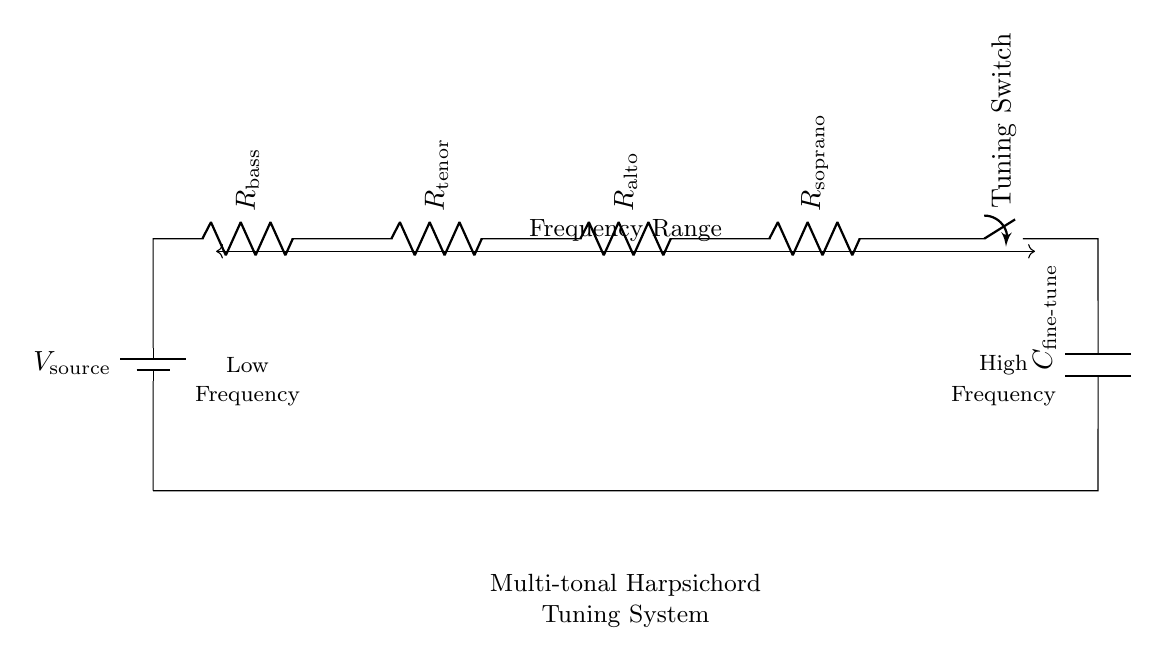What type of circuit is this? The circuit is a series circuit because all components are connected end-to-end in a single path for current to flow.
Answer: Series circuit How many resistors are present in the circuit? There are four resistors visible in the circuit diagram, labeled as bass, tenor, alto, and soprano.
Answer: Four resistors What is the function of the tuning switch? The tuning switch's function is to allow the user to selectively connect or disconnect certain parts of the circuit, modifying the tuning effect on the harpsichord.
Answer: Tuning effect What component is used for fine-tuning? The component used for fine-tuning is the capacitor labeled C fine-tune, which adjusts the network's response for precise tuning adjustments.
Answer: Capacitor What does the frequency range indicate? The frequency range indicates the spectrum of frequencies that the multi-tonal harpsichord can produce, showing low frequencies on the left and high frequencies on the right of the diagram.
Answer: Frequency spectrum How does this circuit affect the sound of the harpsichord? The series connection of resistors can change the sound by altering the voltage across them, allowing for varying tonal qualities and adjustments in timbre based on tuning needs.
Answer: Alters sound What can be inferred when the switch is open? When the switch is open, it interrupts the current flow in the circuit, effectively muting the harpsichord or preventing any tuning adjustments from taking effect.
Answer: Circuit muted 